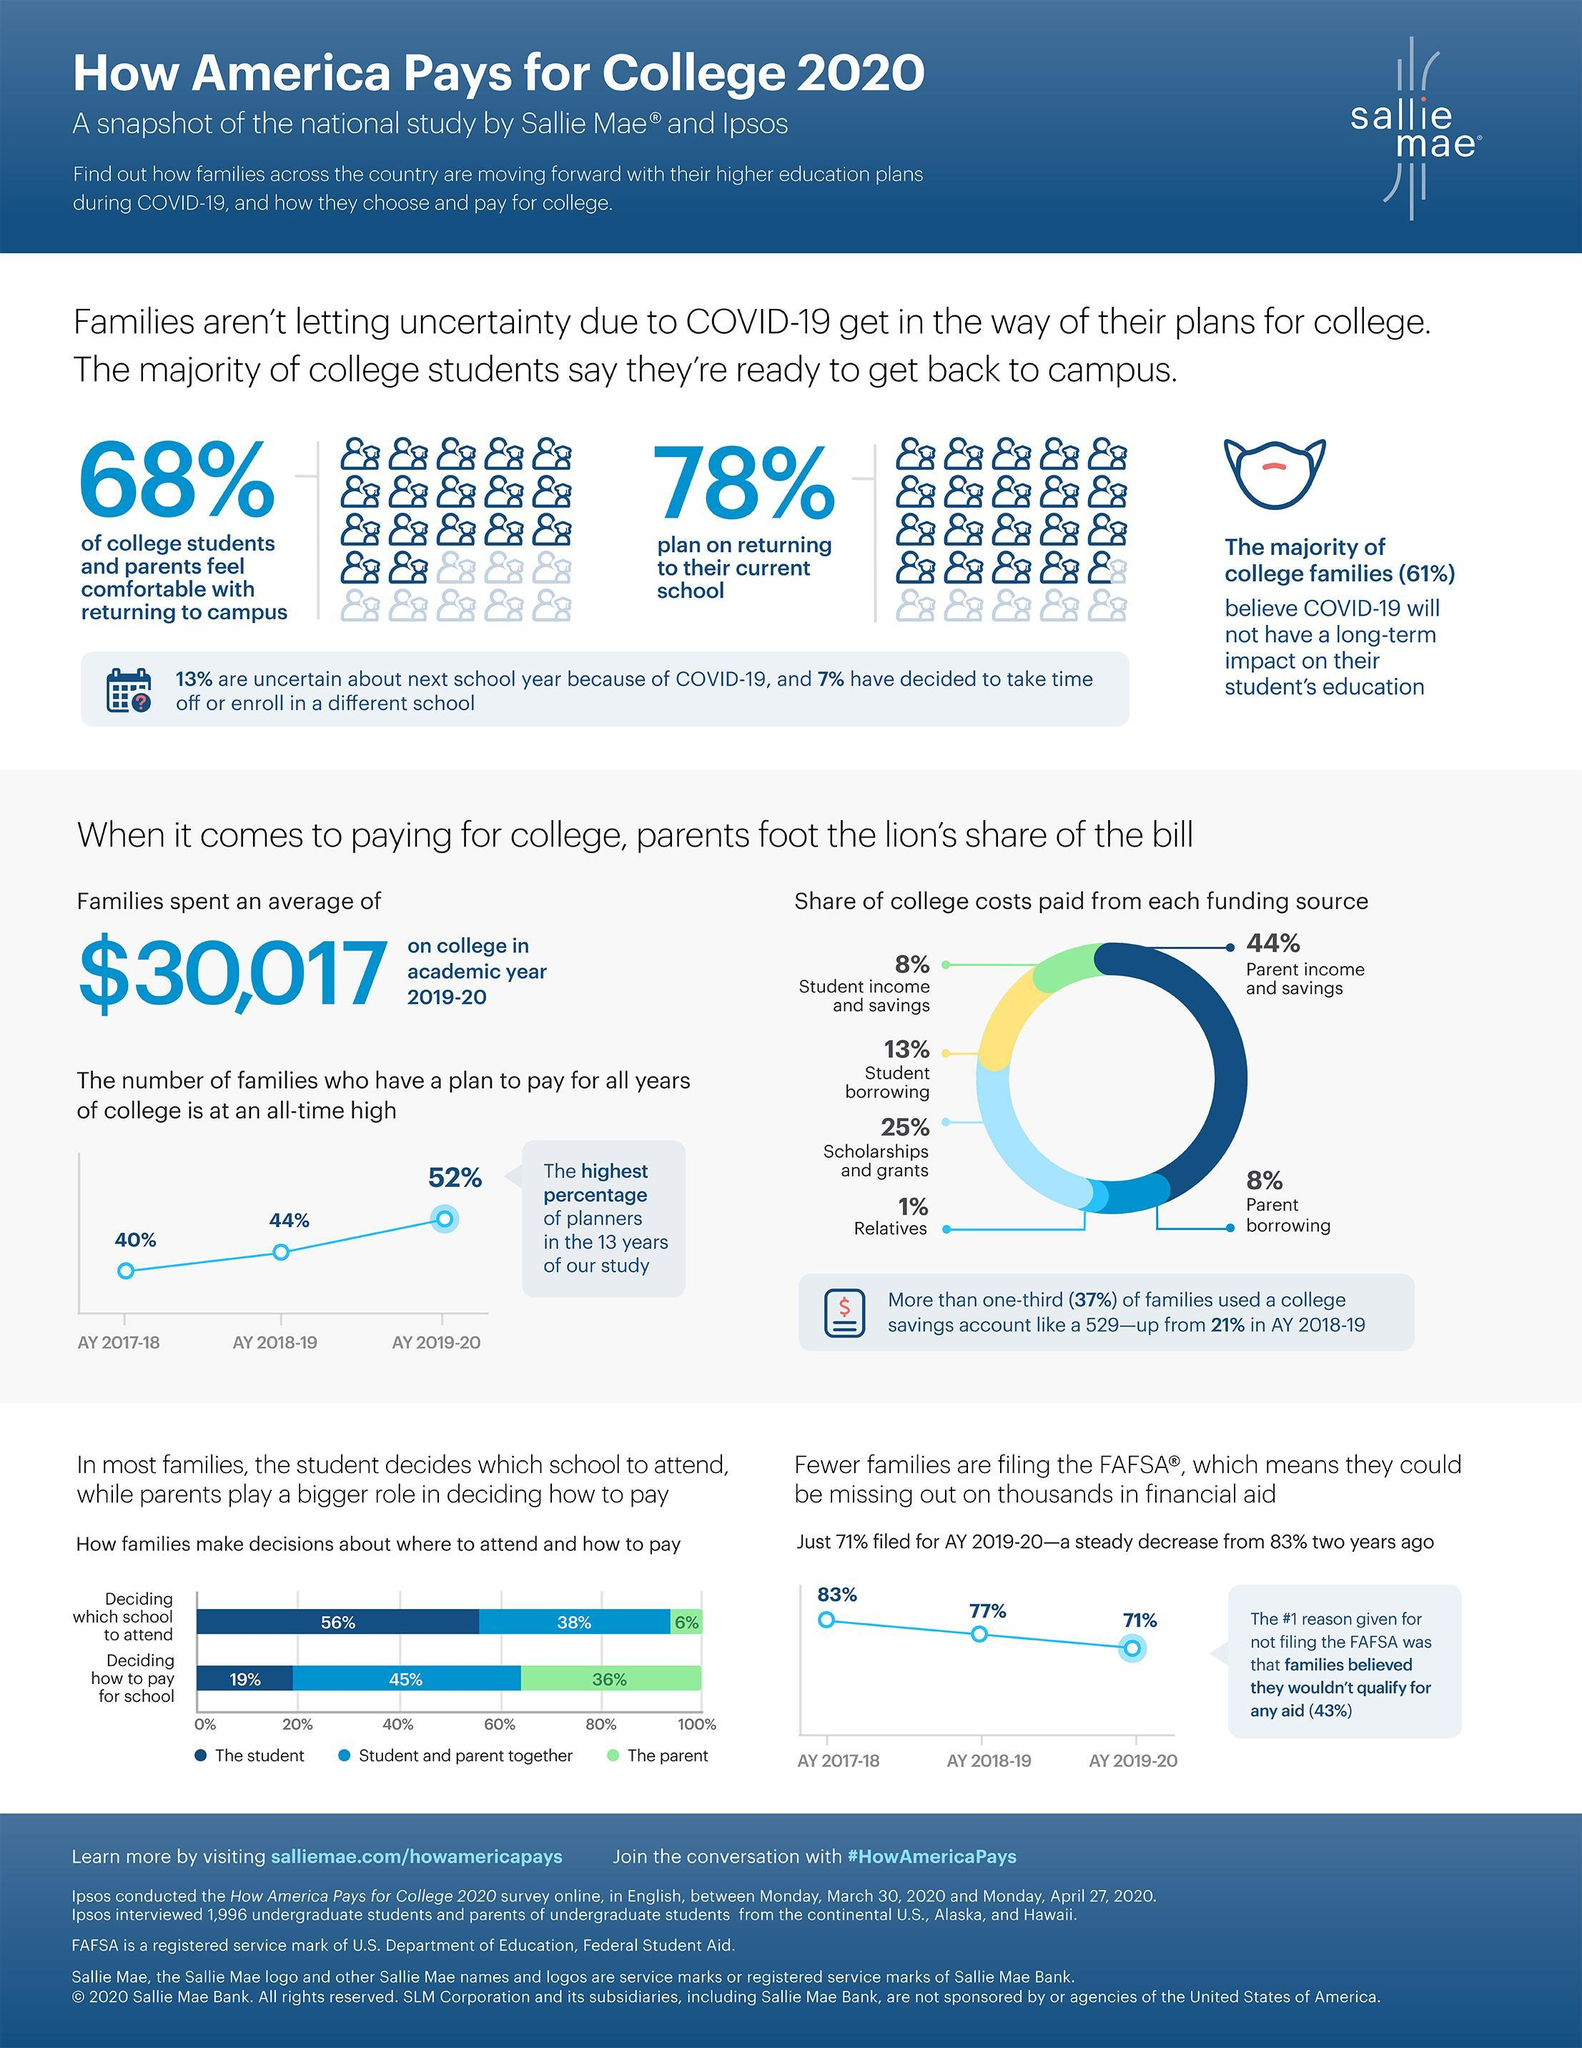what is the percentage of college fund from student borrowing and scholarships/grants combined?
Answer the question with a short phrase. 38 What is the percentage of families in which the decision of student is considered on which school to attend? 94 What is the percentage of decision taken by student alone on how to pay for school ? 19 What is the percentage of decision taken by parent and student together on which school to attend? 38 What is the percentage of decision taken by parent alone on how to pay for school ? 36% what is the percentage of college fund coming from other than parent income and savings? 56 what is the percentage of college fund from student income and parent borrowing combined? 16% What is the percentage of decision taken by parent alone on which school to attend? 6 What is the percentage of families in which the decision of parent is considered on how to pay for school? 81% what percent of students are not planning to return to their current school? 22 What is the percentage of decision taken by parent and student together on how to pay for school ? 45 what percent of students or parents are not feeling comfortable with returning to college? 32 Which is the major source of fund for college? parent income and savings Which is the smallest source of fund for college? relatives what is the percentage of college fund from student borrowing and parent borrowing combined? 21% 